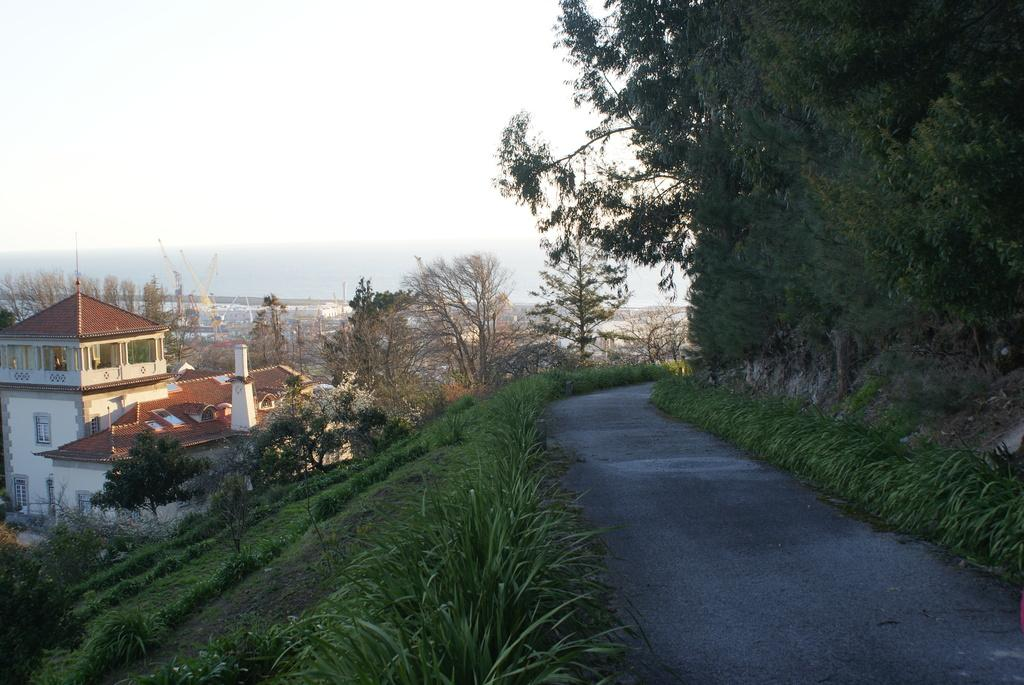What type of structure is present in the image? There is a house in the image. What else can be seen in the image besides the house? There is a road and trees in the image. What is visible in the background of the image? The sky is visible in the image. What direction is the lock facing in the image? There is no lock present in the image. What type of work is being done in the image? There is no indication of any work being done in the image. 